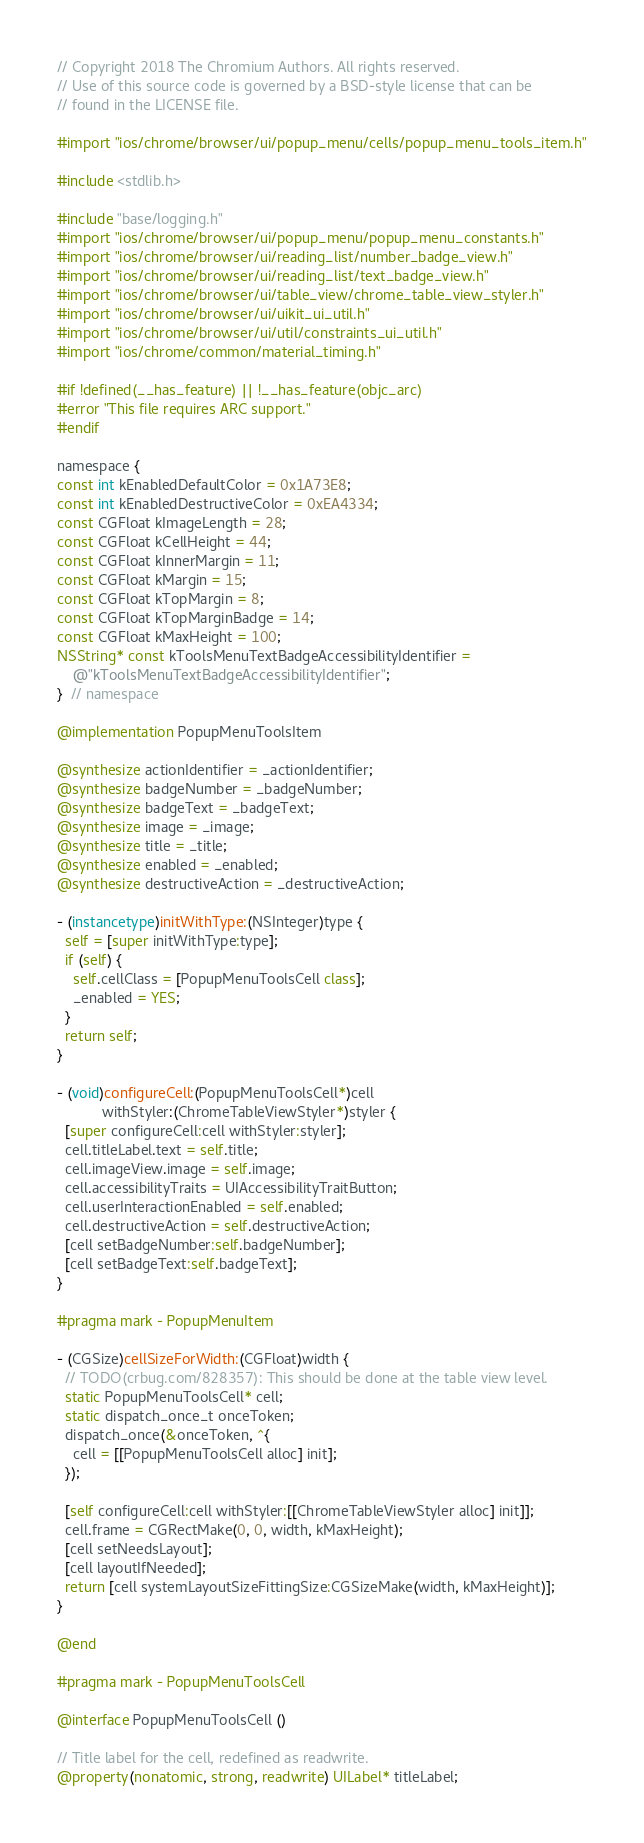Convert code to text. <code><loc_0><loc_0><loc_500><loc_500><_ObjectiveC_>// Copyright 2018 The Chromium Authors. All rights reserved.
// Use of this source code is governed by a BSD-style license that can be
// found in the LICENSE file.

#import "ios/chrome/browser/ui/popup_menu/cells/popup_menu_tools_item.h"

#include <stdlib.h>

#include "base/logging.h"
#import "ios/chrome/browser/ui/popup_menu/popup_menu_constants.h"
#import "ios/chrome/browser/ui/reading_list/number_badge_view.h"
#import "ios/chrome/browser/ui/reading_list/text_badge_view.h"
#import "ios/chrome/browser/ui/table_view/chrome_table_view_styler.h"
#import "ios/chrome/browser/ui/uikit_ui_util.h"
#import "ios/chrome/browser/ui/util/constraints_ui_util.h"
#import "ios/chrome/common/material_timing.h"

#if !defined(__has_feature) || !__has_feature(objc_arc)
#error "This file requires ARC support."
#endif

namespace {
const int kEnabledDefaultColor = 0x1A73E8;
const int kEnabledDestructiveColor = 0xEA4334;
const CGFloat kImageLength = 28;
const CGFloat kCellHeight = 44;
const CGFloat kInnerMargin = 11;
const CGFloat kMargin = 15;
const CGFloat kTopMargin = 8;
const CGFloat kTopMarginBadge = 14;
const CGFloat kMaxHeight = 100;
NSString* const kToolsMenuTextBadgeAccessibilityIdentifier =
    @"kToolsMenuTextBadgeAccessibilityIdentifier";
}  // namespace

@implementation PopupMenuToolsItem

@synthesize actionIdentifier = _actionIdentifier;
@synthesize badgeNumber = _badgeNumber;
@synthesize badgeText = _badgeText;
@synthesize image = _image;
@synthesize title = _title;
@synthesize enabled = _enabled;
@synthesize destructiveAction = _destructiveAction;

- (instancetype)initWithType:(NSInteger)type {
  self = [super initWithType:type];
  if (self) {
    self.cellClass = [PopupMenuToolsCell class];
    _enabled = YES;
  }
  return self;
}

- (void)configureCell:(PopupMenuToolsCell*)cell
           withStyler:(ChromeTableViewStyler*)styler {
  [super configureCell:cell withStyler:styler];
  cell.titleLabel.text = self.title;
  cell.imageView.image = self.image;
  cell.accessibilityTraits = UIAccessibilityTraitButton;
  cell.userInteractionEnabled = self.enabled;
  cell.destructiveAction = self.destructiveAction;
  [cell setBadgeNumber:self.badgeNumber];
  [cell setBadgeText:self.badgeText];
}

#pragma mark - PopupMenuItem

- (CGSize)cellSizeForWidth:(CGFloat)width {
  // TODO(crbug.com/828357): This should be done at the table view level.
  static PopupMenuToolsCell* cell;
  static dispatch_once_t onceToken;
  dispatch_once(&onceToken, ^{
    cell = [[PopupMenuToolsCell alloc] init];
  });

  [self configureCell:cell withStyler:[[ChromeTableViewStyler alloc] init]];
  cell.frame = CGRectMake(0, 0, width, kMaxHeight);
  [cell setNeedsLayout];
  [cell layoutIfNeeded];
  return [cell systemLayoutSizeFittingSize:CGSizeMake(width, kMaxHeight)];
}

@end

#pragma mark - PopupMenuToolsCell

@interface PopupMenuToolsCell ()

// Title label for the cell, redefined as readwrite.
@property(nonatomic, strong, readwrite) UILabel* titleLabel;</code> 